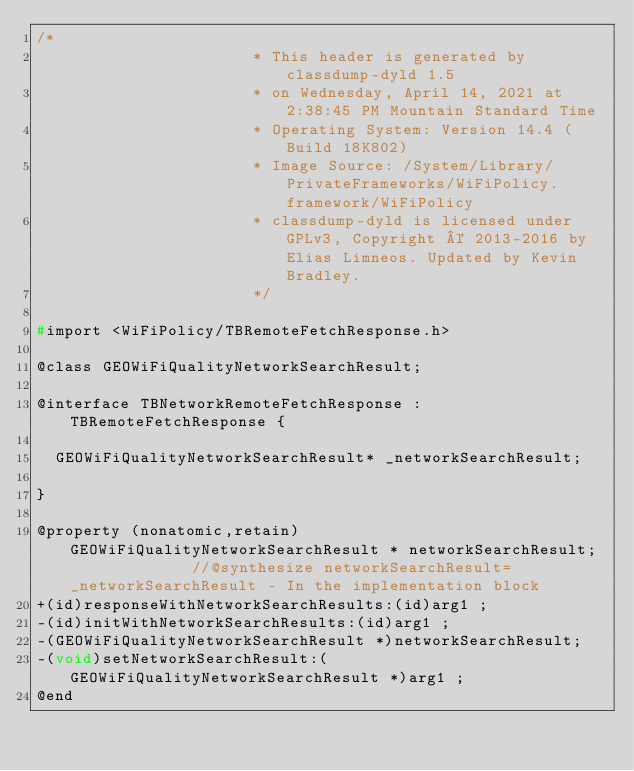<code> <loc_0><loc_0><loc_500><loc_500><_C_>/*
                       * This header is generated by classdump-dyld 1.5
                       * on Wednesday, April 14, 2021 at 2:38:45 PM Mountain Standard Time
                       * Operating System: Version 14.4 (Build 18K802)
                       * Image Source: /System/Library/PrivateFrameworks/WiFiPolicy.framework/WiFiPolicy
                       * classdump-dyld is licensed under GPLv3, Copyright © 2013-2016 by Elias Limneos. Updated by Kevin Bradley.
                       */

#import <WiFiPolicy/TBRemoteFetchResponse.h>

@class GEOWiFiQualityNetworkSearchResult;

@interface TBNetworkRemoteFetchResponse : TBRemoteFetchResponse {

	GEOWiFiQualityNetworkSearchResult* _networkSearchResult;

}

@property (nonatomic,retain) GEOWiFiQualityNetworkSearchResult * networkSearchResult;              //@synthesize networkSearchResult=_networkSearchResult - In the implementation block
+(id)responseWithNetworkSearchResults:(id)arg1 ;
-(id)initWithNetworkSearchResults:(id)arg1 ;
-(GEOWiFiQualityNetworkSearchResult *)networkSearchResult;
-(void)setNetworkSearchResult:(GEOWiFiQualityNetworkSearchResult *)arg1 ;
@end

</code> 